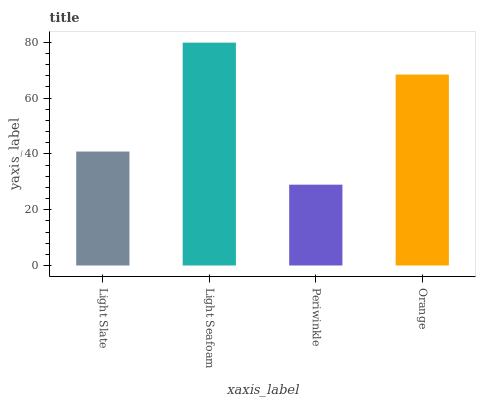Is Periwinkle the minimum?
Answer yes or no. Yes. Is Light Seafoam the maximum?
Answer yes or no. Yes. Is Light Seafoam the minimum?
Answer yes or no. No. Is Periwinkle the maximum?
Answer yes or no. No. Is Light Seafoam greater than Periwinkle?
Answer yes or no. Yes. Is Periwinkle less than Light Seafoam?
Answer yes or no. Yes. Is Periwinkle greater than Light Seafoam?
Answer yes or no. No. Is Light Seafoam less than Periwinkle?
Answer yes or no. No. Is Orange the high median?
Answer yes or no. Yes. Is Light Slate the low median?
Answer yes or no. Yes. Is Periwinkle the high median?
Answer yes or no. No. Is Orange the low median?
Answer yes or no. No. 